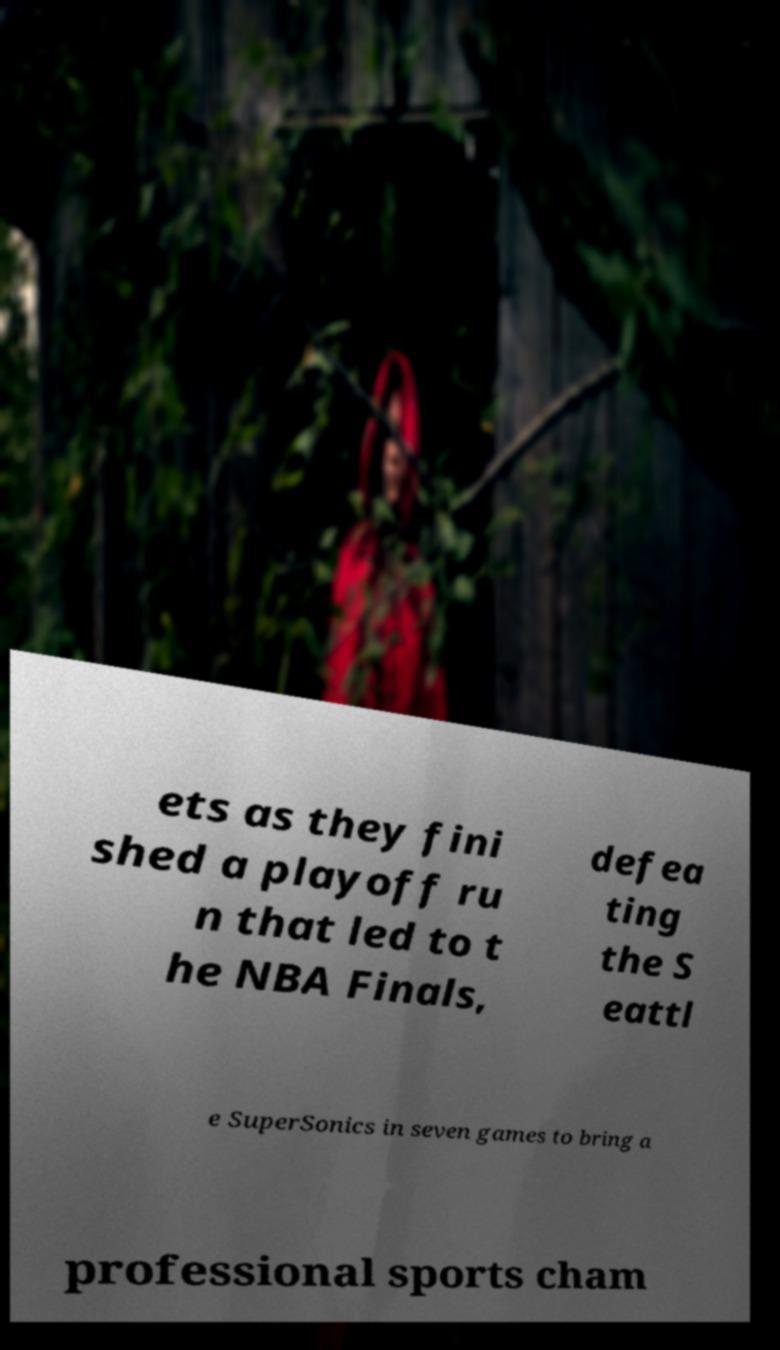For documentation purposes, I need the text within this image transcribed. Could you provide that? ets as they fini shed a playoff ru n that led to t he NBA Finals, defea ting the S eattl e SuperSonics in seven games to bring a professional sports cham 